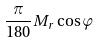Convert formula to latex. <formula><loc_0><loc_0><loc_500><loc_500>\frac { \pi } { 1 8 0 } M _ { r } \cos \varphi</formula> 